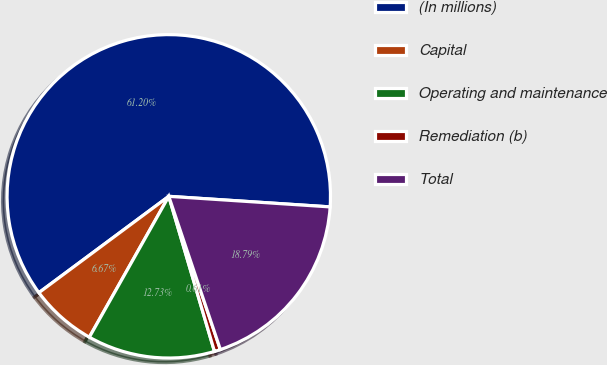<chart> <loc_0><loc_0><loc_500><loc_500><pie_chart><fcel>(In millions)<fcel>Capital<fcel>Operating and maintenance<fcel>Remediation (b)<fcel>Total<nl><fcel>61.2%<fcel>6.67%<fcel>12.73%<fcel>0.61%<fcel>18.79%<nl></chart> 